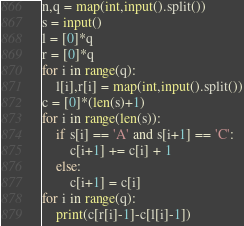<code> <loc_0><loc_0><loc_500><loc_500><_Python_>n,q = map(int,input().split())
s = input()
l = [0]*q
r = [0]*q
for i in range(q):
	l[i],r[i] = map(int,input().split())
c = [0]*(len(s)+1)
for i in range(len(s)):
	if s[i] == 'A' and s[i+1] == 'C':
		c[i+1] += c[i] + 1
	else:
		c[i+1] = c[i]
for i in range(q):
	print(c[r[i]-1]-c[l[i]-1])</code> 